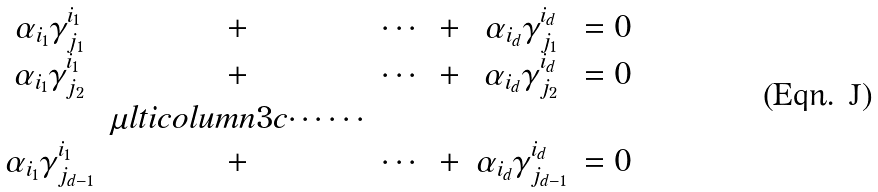<formula> <loc_0><loc_0><loc_500><loc_500>\begin{matrix} \alpha _ { i _ { 1 } } \gamma _ { j _ { 1 } } ^ { i _ { 1 } } & + & \cdots & + & \alpha _ { i _ { d } } \gamma _ { j _ { 1 } } ^ { i _ { d } } & = 0 \\ \alpha _ { i _ { 1 } } \gamma _ { j _ { 2 } } ^ { i _ { 1 } } & + & \cdots & + & \alpha _ { i _ { d } } \gamma _ { j _ { 2 } } ^ { i _ { d } } & = 0 \\ & \mu l t i c o l u m n { 3 } { c } { \cdots \cdots } \\ \alpha _ { i _ { 1 } } \gamma _ { j _ { d - 1 } } ^ { i _ { 1 } } & + & \cdots & + & \alpha _ { i _ { d } } \gamma _ { j _ { d - 1 } } ^ { i _ { d } } & = 0 \end{matrix}</formula> 